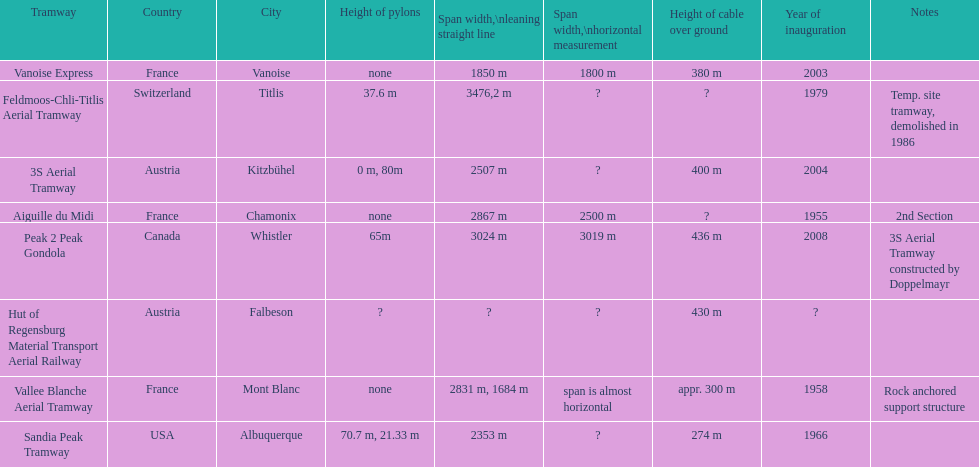How much longer is the peak 2 peak gondola than the 32 aerial tramway? 517. 